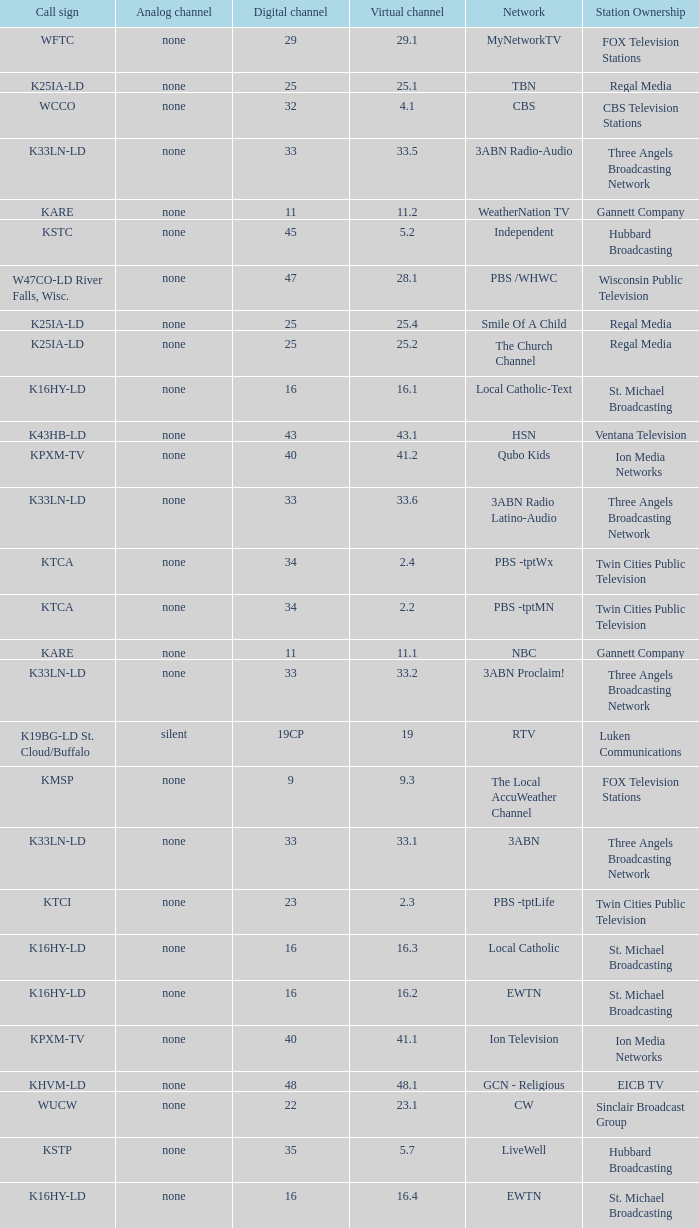Call sign of k43hb-ld is what virtual channel? 43.1. 